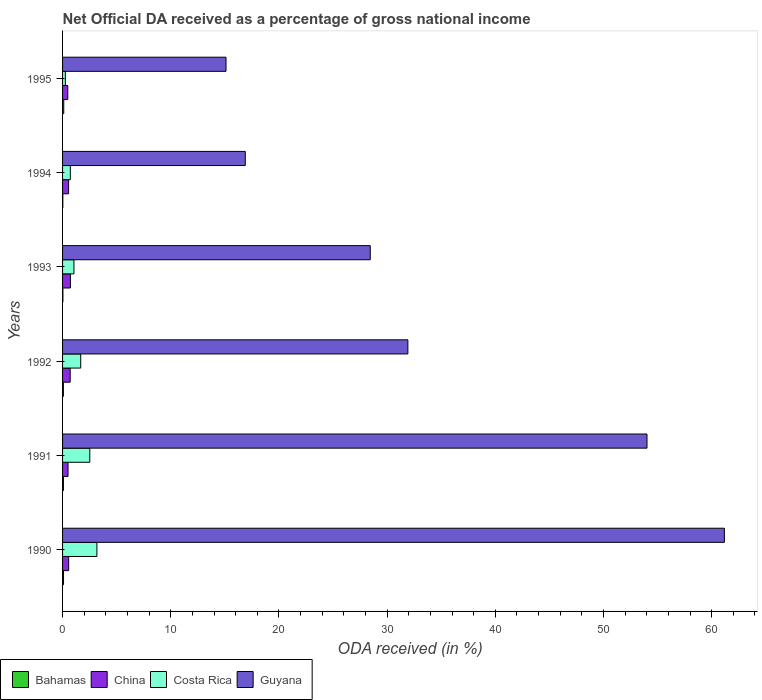How many bars are there on the 6th tick from the top?
Your response must be concise. 4. How many bars are there on the 3rd tick from the bottom?
Your answer should be compact. 4. What is the net official DA received in Costa Rica in 1993?
Offer a very short reply. 1.05. Across all years, what is the maximum net official DA received in China?
Keep it short and to the point. 0.73. Across all years, what is the minimum net official DA received in Guyana?
Provide a succinct answer. 15.11. What is the total net official DA received in Guyana in the graph?
Your answer should be very brief. 207.54. What is the difference between the net official DA received in Costa Rica in 1990 and that in 1995?
Offer a terse response. 2.92. What is the difference between the net official DA received in Bahamas in 1994 and the net official DA received in China in 1993?
Your response must be concise. -0.7. What is the average net official DA received in China per year?
Ensure brevity in your answer.  0.59. In the year 1991, what is the difference between the net official DA received in Guyana and net official DA received in Costa Rica?
Your response must be concise. 51.5. What is the ratio of the net official DA received in Costa Rica in 1993 to that in 1995?
Provide a short and direct response. 4.08. Is the net official DA received in Guyana in 1993 less than that in 1995?
Your response must be concise. No. What is the difference between the highest and the second highest net official DA received in China?
Your answer should be very brief. 0.02. What is the difference between the highest and the lowest net official DA received in China?
Offer a very short reply. 0.24. In how many years, is the net official DA received in China greater than the average net official DA received in China taken over all years?
Provide a short and direct response. 2. Is it the case that in every year, the sum of the net official DA received in Bahamas and net official DA received in Costa Rica is greater than the sum of net official DA received in Guyana and net official DA received in China?
Keep it short and to the point. No. What does the 4th bar from the top in 1993 represents?
Provide a succinct answer. Bahamas. Is it the case that in every year, the sum of the net official DA received in Costa Rica and net official DA received in China is greater than the net official DA received in Guyana?
Ensure brevity in your answer.  No. Are all the bars in the graph horizontal?
Provide a succinct answer. Yes. How many years are there in the graph?
Provide a succinct answer. 6. Are the values on the major ticks of X-axis written in scientific E-notation?
Your response must be concise. No. Does the graph contain any zero values?
Ensure brevity in your answer.  No. How are the legend labels stacked?
Offer a very short reply. Horizontal. What is the title of the graph?
Offer a terse response. Net Official DA received as a percentage of gross national income. What is the label or title of the X-axis?
Provide a succinct answer. ODA received (in %). What is the label or title of the Y-axis?
Your answer should be very brief. Years. What is the ODA received (in %) in Bahamas in 1990?
Provide a succinct answer. 0.09. What is the ODA received (in %) of China in 1990?
Provide a succinct answer. 0.56. What is the ODA received (in %) in Costa Rica in 1990?
Offer a very short reply. 3.17. What is the ODA received (in %) of Guyana in 1990?
Provide a succinct answer. 61.17. What is the ODA received (in %) of Bahamas in 1991?
Keep it short and to the point. 0.08. What is the ODA received (in %) in China in 1991?
Offer a very short reply. 0.51. What is the ODA received (in %) in Costa Rica in 1991?
Ensure brevity in your answer.  2.52. What is the ODA received (in %) in Guyana in 1991?
Give a very brief answer. 54.02. What is the ODA received (in %) in Bahamas in 1992?
Offer a terse response. 0.08. What is the ODA received (in %) of China in 1992?
Give a very brief answer. 0.7. What is the ODA received (in %) in Costa Rica in 1992?
Ensure brevity in your answer.  1.68. What is the ODA received (in %) in Guyana in 1992?
Your answer should be compact. 31.92. What is the ODA received (in %) of Bahamas in 1993?
Your response must be concise. 0.03. What is the ODA received (in %) of China in 1993?
Keep it short and to the point. 0.73. What is the ODA received (in %) in Costa Rica in 1993?
Your response must be concise. 1.05. What is the ODA received (in %) of Guyana in 1993?
Make the answer very short. 28.44. What is the ODA received (in %) of Bahamas in 1994?
Give a very brief answer. 0.02. What is the ODA received (in %) of China in 1994?
Offer a terse response. 0.56. What is the ODA received (in %) in Costa Rica in 1994?
Make the answer very short. 0.72. What is the ODA received (in %) of Guyana in 1994?
Provide a short and direct response. 16.89. What is the ODA received (in %) in Bahamas in 1995?
Offer a very short reply. 0.11. What is the ODA received (in %) in China in 1995?
Give a very brief answer. 0.48. What is the ODA received (in %) of Costa Rica in 1995?
Offer a very short reply. 0.26. What is the ODA received (in %) in Guyana in 1995?
Your answer should be very brief. 15.11. Across all years, what is the maximum ODA received (in %) of Bahamas?
Give a very brief answer. 0.11. Across all years, what is the maximum ODA received (in %) of China?
Ensure brevity in your answer.  0.73. Across all years, what is the maximum ODA received (in %) in Costa Rica?
Your answer should be very brief. 3.17. Across all years, what is the maximum ODA received (in %) in Guyana?
Your response must be concise. 61.17. Across all years, what is the minimum ODA received (in %) of Bahamas?
Keep it short and to the point. 0.02. Across all years, what is the minimum ODA received (in %) of China?
Make the answer very short. 0.48. Across all years, what is the minimum ODA received (in %) in Costa Rica?
Provide a short and direct response. 0.26. Across all years, what is the minimum ODA received (in %) of Guyana?
Make the answer very short. 15.11. What is the total ODA received (in %) in Bahamas in the graph?
Offer a very short reply. 0.41. What is the total ODA received (in %) in China in the graph?
Keep it short and to the point. 3.54. What is the total ODA received (in %) of Costa Rica in the graph?
Make the answer very short. 9.4. What is the total ODA received (in %) of Guyana in the graph?
Your answer should be compact. 207.54. What is the difference between the ODA received (in %) of Bahamas in 1990 and that in 1991?
Keep it short and to the point. 0.01. What is the difference between the ODA received (in %) in China in 1990 and that in 1991?
Offer a terse response. 0.06. What is the difference between the ODA received (in %) of Costa Rica in 1990 and that in 1991?
Ensure brevity in your answer.  0.66. What is the difference between the ODA received (in %) of Guyana in 1990 and that in 1991?
Provide a succinct answer. 7.15. What is the difference between the ODA received (in %) in Bahamas in 1990 and that in 1992?
Offer a very short reply. 0.01. What is the difference between the ODA received (in %) in China in 1990 and that in 1992?
Your answer should be very brief. -0.14. What is the difference between the ODA received (in %) in Costa Rica in 1990 and that in 1992?
Keep it short and to the point. 1.5. What is the difference between the ODA received (in %) of Guyana in 1990 and that in 1992?
Provide a succinct answer. 29.26. What is the difference between the ODA received (in %) of Bahamas in 1990 and that in 1993?
Your response must be concise. 0.06. What is the difference between the ODA received (in %) in China in 1990 and that in 1993?
Your answer should be very brief. -0.16. What is the difference between the ODA received (in %) in Costa Rica in 1990 and that in 1993?
Keep it short and to the point. 2.12. What is the difference between the ODA received (in %) in Guyana in 1990 and that in 1993?
Make the answer very short. 32.73. What is the difference between the ODA received (in %) of Bahamas in 1990 and that in 1994?
Keep it short and to the point. 0.07. What is the difference between the ODA received (in %) in China in 1990 and that in 1994?
Offer a terse response. 0.01. What is the difference between the ODA received (in %) of Costa Rica in 1990 and that in 1994?
Provide a succinct answer. 2.46. What is the difference between the ODA received (in %) of Guyana in 1990 and that in 1994?
Your answer should be very brief. 44.28. What is the difference between the ODA received (in %) of Bahamas in 1990 and that in 1995?
Your answer should be compact. -0.02. What is the difference between the ODA received (in %) of China in 1990 and that in 1995?
Give a very brief answer. 0.08. What is the difference between the ODA received (in %) in Costa Rica in 1990 and that in 1995?
Provide a succinct answer. 2.92. What is the difference between the ODA received (in %) in Guyana in 1990 and that in 1995?
Give a very brief answer. 46.07. What is the difference between the ODA received (in %) in Bahamas in 1991 and that in 1992?
Provide a short and direct response. 0. What is the difference between the ODA received (in %) of China in 1991 and that in 1992?
Give a very brief answer. -0.2. What is the difference between the ODA received (in %) of Costa Rica in 1991 and that in 1992?
Provide a short and direct response. 0.84. What is the difference between the ODA received (in %) in Guyana in 1991 and that in 1992?
Your answer should be compact. 22.1. What is the difference between the ODA received (in %) of Bahamas in 1991 and that in 1993?
Your response must be concise. 0.05. What is the difference between the ODA received (in %) in China in 1991 and that in 1993?
Your response must be concise. -0.22. What is the difference between the ODA received (in %) in Costa Rica in 1991 and that in 1993?
Provide a short and direct response. 1.46. What is the difference between the ODA received (in %) in Guyana in 1991 and that in 1993?
Your answer should be compact. 25.58. What is the difference between the ODA received (in %) of Bahamas in 1991 and that in 1994?
Your answer should be compact. 0.06. What is the difference between the ODA received (in %) in China in 1991 and that in 1994?
Offer a very short reply. -0.05. What is the difference between the ODA received (in %) of Costa Rica in 1991 and that in 1994?
Ensure brevity in your answer.  1.8. What is the difference between the ODA received (in %) in Guyana in 1991 and that in 1994?
Offer a terse response. 37.13. What is the difference between the ODA received (in %) in Bahamas in 1991 and that in 1995?
Give a very brief answer. -0.03. What is the difference between the ODA received (in %) of China in 1991 and that in 1995?
Give a very brief answer. 0.02. What is the difference between the ODA received (in %) in Costa Rica in 1991 and that in 1995?
Keep it short and to the point. 2.26. What is the difference between the ODA received (in %) of Guyana in 1991 and that in 1995?
Give a very brief answer. 38.91. What is the difference between the ODA received (in %) of Bahamas in 1992 and that in 1993?
Make the answer very short. 0.05. What is the difference between the ODA received (in %) in China in 1992 and that in 1993?
Offer a very short reply. -0.02. What is the difference between the ODA received (in %) in Costa Rica in 1992 and that in 1993?
Your answer should be compact. 0.62. What is the difference between the ODA received (in %) of Guyana in 1992 and that in 1993?
Offer a terse response. 3.48. What is the difference between the ODA received (in %) of Bahamas in 1992 and that in 1994?
Make the answer very short. 0.05. What is the difference between the ODA received (in %) of China in 1992 and that in 1994?
Ensure brevity in your answer.  0.14. What is the difference between the ODA received (in %) in Costa Rica in 1992 and that in 1994?
Offer a very short reply. 0.96. What is the difference between the ODA received (in %) in Guyana in 1992 and that in 1994?
Make the answer very short. 15.03. What is the difference between the ODA received (in %) in Bahamas in 1992 and that in 1995?
Your response must be concise. -0.03. What is the difference between the ODA received (in %) in China in 1992 and that in 1995?
Offer a terse response. 0.22. What is the difference between the ODA received (in %) in Costa Rica in 1992 and that in 1995?
Offer a terse response. 1.42. What is the difference between the ODA received (in %) of Guyana in 1992 and that in 1995?
Your response must be concise. 16.81. What is the difference between the ODA received (in %) of Bahamas in 1993 and that in 1994?
Ensure brevity in your answer.  0.01. What is the difference between the ODA received (in %) in China in 1993 and that in 1994?
Make the answer very short. 0.17. What is the difference between the ODA received (in %) in Costa Rica in 1993 and that in 1994?
Offer a very short reply. 0.34. What is the difference between the ODA received (in %) in Guyana in 1993 and that in 1994?
Your answer should be very brief. 11.55. What is the difference between the ODA received (in %) in Bahamas in 1993 and that in 1995?
Offer a terse response. -0.08. What is the difference between the ODA received (in %) of China in 1993 and that in 1995?
Give a very brief answer. 0.24. What is the difference between the ODA received (in %) of Costa Rica in 1993 and that in 1995?
Provide a succinct answer. 0.8. What is the difference between the ODA received (in %) of Guyana in 1993 and that in 1995?
Offer a terse response. 13.33. What is the difference between the ODA received (in %) of Bahamas in 1994 and that in 1995?
Make the answer very short. -0.09. What is the difference between the ODA received (in %) of China in 1994 and that in 1995?
Offer a very short reply. 0.08. What is the difference between the ODA received (in %) of Costa Rica in 1994 and that in 1995?
Make the answer very short. 0.46. What is the difference between the ODA received (in %) of Guyana in 1994 and that in 1995?
Keep it short and to the point. 1.78. What is the difference between the ODA received (in %) in Bahamas in 1990 and the ODA received (in %) in China in 1991?
Offer a very short reply. -0.42. What is the difference between the ODA received (in %) of Bahamas in 1990 and the ODA received (in %) of Costa Rica in 1991?
Keep it short and to the point. -2.43. What is the difference between the ODA received (in %) in Bahamas in 1990 and the ODA received (in %) in Guyana in 1991?
Make the answer very short. -53.93. What is the difference between the ODA received (in %) of China in 1990 and the ODA received (in %) of Costa Rica in 1991?
Ensure brevity in your answer.  -1.95. What is the difference between the ODA received (in %) of China in 1990 and the ODA received (in %) of Guyana in 1991?
Ensure brevity in your answer.  -53.45. What is the difference between the ODA received (in %) of Costa Rica in 1990 and the ODA received (in %) of Guyana in 1991?
Your response must be concise. -50.84. What is the difference between the ODA received (in %) in Bahamas in 1990 and the ODA received (in %) in China in 1992?
Provide a succinct answer. -0.62. What is the difference between the ODA received (in %) of Bahamas in 1990 and the ODA received (in %) of Costa Rica in 1992?
Keep it short and to the point. -1.59. What is the difference between the ODA received (in %) of Bahamas in 1990 and the ODA received (in %) of Guyana in 1992?
Offer a terse response. -31.83. What is the difference between the ODA received (in %) of China in 1990 and the ODA received (in %) of Costa Rica in 1992?
Ensure brevity in your answer.  -1.11. What is the difference between the ODA received (in %) in China in 1990 and the ODA received (in %) in Guyana in 1992?
Make the answer very short. -31.35. What is the difference between the ODA received (in %) of Costa Rica in 1990 and the ODA received (in %) of Guyana in 1992?
Provide a short and direct response. -28.74. What is the difference between the ODA received (in %) in Bahamas in 1990 and the ODA received (in %) in China in 1993?
Provide a short and direct response. -0.64. What is the difference between the ODA received (in %) of Bahamas in 1990 and the ODA received (in %) of Costa Rica in 1993?
Your response must be concise. -0.96. What is the difference between the ODA received (in %) in Bahamas in 1990 and the ODA received (in %) in Guyana in 1993?
Provide a succinct answer. -28.35. What is the difference between the ODA received (in %) of China in 1990 and the ODA received (in %) of Costa Rica in 1993?
Your answer should be compact. -0.49. What is the difference between the ODA received (in %) of China in 1990 and the ODA received (in %) of Guyana in 1993?
Keep it short and to the point. -27.88. What is the difference between the ODA received (in %) of Costa Rica in 1990 and the ODA received (in %) of Guyana in 1993?
Offer a terse response. -25.27. What is the difference between the ODA received (in %) of Bahamas in 1990 and the ODA received (in %) of China in 1994?
Offer a terse response. -0.47. What is the difference between the ODA received (in %) of Bahamas in 1990 and the ODA received (in %) of Costa Rica in 1994?
Make the answer very short. -0.63. What is the difference between the ODA received (in %) of Bahamas in 1990 and the ODA received (in %) of Guyana in 1994?
Keep it short and to the point. -16.8. What is the difference between the ODA received (in %) of China in 1990 and the ODA received (in %) of Costa Rica in 1994?
Offer a terse response. -0.15. What is the difference between the ODA received (in %) of China in 1990 and the ODA received (in %) of Guyana in 1994?
Your response must be concise. -16.32. What is the difference between the ODA received (in %) of Costa Rica in 1990 and the ODA received (in %) of Guyana in 1994?
Make the answer very short. -13.71. What is the difference between the ODA received (in %) of Bahamas in 1990 and the ODA received (in %) of China in 1995?
Keep it short and to the point. -0.39. What is the difference between the ODA received (in %) of Bahamas in 1990 and the ODA received (in %) of Costa Rica in 1995?
Your response must be concise. -0.17. What is the difference between the ODA received (in %) of Bahamas in 1990 and the ODA received (in %) of Guyana in 1995?
Provide a succinct answer. -15.02. What is the difference between the ODA received (in %) in China in 1990 and the ODA received (in %) in Costa Rica in 1995?
Ensure brevity in your answer.  0.31. What is the difference between the ODA received (in %) in China in 1990 and the ODA received (in %) in Guyana in 1995?
Offer a very short reply. -14.54. What is the difference between the ODA received (in %) of Costa Rica in 1990 and the ODA received (in %) of Guyana in 1995?
Offer a very short reply. -11.93. What is the difference between the ODA received (in %) of Bahamas in 1991 and the ODA received (in %) of China in 1992?
Provide a succinct answer. -0.62. What is the difference between the ODA received (in %) in Bahamas in 1991 and the ODA received (in %) in Costa Rica in 1992?
Your answer should be very brief. -1.6. What is the difference between the ODA received (in %) of Bahamas in 1991 and the ODA received (in %) of Guyana in 1992?
Your answer should be compact. -31.84. What is the difference between the ODA received (in %) of China in 1991 and the ODA received (in %) of Costa Rica in 1992?
Offer a very short reply. -1.17. What is the difference between the ODA received (in %) of China in 1991 and the ODA received (in %) of Guyana in 1992?
Provide a short and direct response. -31.41. What is the difference between the ODA received (in %) in Costa Rica in 1991 and the ODA received (in %) in Guyana in 1992?
Offer a very short reply. -29.4. What is the difference between the ODA received (in %) in Bahamas in 1991 and the ODA received (in %) in China in 1993?
Offer a terse response. -0.65. What is the difference between the ODA received (in %) of Bahamas in 1991 and the ODA received (in %) of Costa Rica in 1993?
Provide a succinct answer. -0.97. What is the difference between the ODA received (in %) of Bahamas in 1991 and the ODA received (in %) of Guyana in 1993?
Ensure brevity in your answer.  -28.36. What is the difference between the ODA received (in %) in China in 1991 and the ODA received (in %) in Costa Rica in 1993?
Your answer should be very brief. -0.55. What is the difference between the ODA received (in %) in China in 1991 and the ODA received (in %) in Guyana in 1993?
Ensure brevity in your answer.  -27.93. What is the difference between the ODA received (in %) in Costa Rica in 1991 and the ODA received (in %) in Guyana in 1993?
Make the answer very short. -25.92. What is the difference between the ODA received (in %) of Bahamas in 1991 and the ODA received (in %) of China in 1994?
Give a very brief answer. -0.48. What is the difference between the ODA received (in %) in Bahamas in 1991 and the ODA received (in %) in Costa Rica in 1994?
Keep it short and to the point. -0.64. What is the difference between the ODA received (in %) of Bahamas in 1991 and the ODA received (in %) of Guyana in 1994?
Provide a succinct answer. -16.81. What is the difference between the ODA received (in %) in China in 1991 and the ODA received (in %) in Costa Rica in 1994?
Keep it short and to the point. -0.21. What is the difference between the ODA received (in %) in China in 1991 and the ODA received (in %) in Guyana in 1994?
Provide a short and direct response. -16.38. What is the difference between the ODA received (in %) in Costa Rica in 1991 and the ODA received (in %) in Guyana in 1994?
Ensure brevity in your answer.  -14.37. What is the difference between the ODA received (in %) of Bahamas in 1991 and the ODA received (in %) of China in 1995?
Keep it short and to the point. -0.4. What is the difference between the ODA received (in %) of Bahamas in 1991 and the ODA received (in %) of Costa Rica in 1995?
Your answer should be very brief. -0.18. What is the difference between the ODA received (in %) in Bahamas in 1991 and the ODA received (in %) in Guyana in 1995?
Provide a short and direct response. -15.03. What is the difference between the ODA received (in %) of China in 1991 and the ODA received (in %) of Costa Rica in 1995?
Provide a short and direct response. 0.25. What is the difference between the ODA received (in %) in China in 1991 and the ODA received (in %) in Guyana in 1995?
Ensure brevity in your answer.  -14.6. What is the difference between the ODA received (in %) of Costa Rica in 1991 and the ODA received (in %) of Guyana in 1995?
Ensure brevity in your answer.  -12.59. What is the difference between the ODA received (in %) in Bahamas in 1992 and the ODA received (in %) in China in 1993?
Provide a succinct answer. -0.65. What is the difference between the ODA received (in %) in Bahamas in 1992 and the ODA received (in %) in Costa Rica in 1993?
Give a very brief answer. -0.98. What is the difference between the ODA received (in %) of Bahamas in 1992 and the ODA received (in %) of Guyana in 1993?
Your answer should be very brief. -28.36. What is the difference between the ODA received (in %) in China in 1992 and the ODA received (in %) in Costa Rica in 1993?
Provide a short and direct response. -0.35. What is the difference between the ODA received (in %) in China in 1992 and the ODA received (in %) in Guyana in 1993?
Your response must be concise. -27.74. What is the difference between the ODA received (in %) of Costa Rica in 1992 and the ODA received (in %) of Guyana in 1993?
Your response must be concise. -26.76. What is the difference between the ODA received (in %) in Bahamas in 1992 and the ODA received (in %) in China in 1994?
Make the answer very short. -0.48. What is the difference between the ODA received (in %) of Bahamas in 1992 and the ODA received (in %) of Costa Rica in 1994?
Your answer should be very brief. -0.64. What is the difference between the ODA received (in %) in Bahamas in 1992 and the ODA received (in %) in Guyana in 1994?
Your answer should be very brief. -16.81. What is the difference between the ODA received (in %) in China in 1992 and the ODA received (in %) in Costa Rica in 1994?
Offer a very short reply. -0.01. What is the difference between the ODA received (in %) in China in 1992 and the ODA received (in %) in Guyana in 1994?
Ensure brevity in your answer.  -16.18. What is the difference between the ODA received (in %) in Costa Rica in 1992 and the ODA received (in %) in Guyana in 1994?
Make the answer very short. -15.21. What is the difference between the ODA received (in %) in Bahamas in 1992 and the ODA received (in %) in China in 1995?
Offer a terse response. -0.41. What is the difference between the ODA received (in %) in Bahamas in 1992 and the ODA received (in %) in Costa Rica in 1995?
Give a very brief answer. -0.18. What is the difference between the ODA received (in %) of Bahamas in 1992 and the ODA received (in %) of Guyana in 1995?
Give a very brief answer. -15.03. What is the difference between the ODA received (in %) of China in 1992 and the ODA received (in %) of Costa Rica in 1995?
Offer a terse response. 0.45. What is the difference between the ODA received (in %) in China in 1992 and the ODA received (in %) in Guyana in 1995?
Give a very brief answer. -14.4. What is the difference between the ODA received (in %) of Costa Rica in 1992 and the ODA received (in %) of Guyana in 1995?
Provide a succinct answer. -13.43. What is the difference between the ODA received (in %) in Bahamas in 1993 and the ODA received (in %) in China in 1994?
Ensure brevity in your answer.  -0.53. What is the difference between the ODA received (in %) in Bahamas in 1993 and the ODA received (in %) in Costa Rica in 1994?
Ensure brevity in your answer.  -0.69. What is the difference between the ODA received (in %) in Bahamas in 1993 and the ODA received (in %) in Guyana in 1994?
Make the answer very short. -16.86. What is the difference between the ODA received (in %) of China in 1993 and the ODA received (in %) of Costa Rica in 1994?
Provide a succinct answer. 0.01. What is the difference between the ODA received (in %) in China in 1993 and the ODA received (in %) in Guyana in 1994?
Keep it short and to the point. -16.16. What is the difference between the ODA received (in %) in Costa Rica in 1993 and the ODA received (in %) in Guyana in 1994?
Make the answer very short. -15.83. What is the difference between the ODA received (in %) of Bahamas in 1993 and the ODA received (in %) of China in 1995?
Give a very brief answer. -0.45. What is the difference between the ODA received (in %) in Bahamas in 1993 and the ODA received (in %) in Costa Rica in 1995?
Offer a very short reply. -0.23. What is the difference between the ODA received (in %) of Bahamas in 1993 and the ODA received (in %) of Guyana in 1995?
Your answer should be compact. -15.08. What is the difference between the ODA received (in %) in China in 1993 and the ODA received (in %) in Costa Rica in 1995?
Offer a very short reply. 0.47. What is the difference between the ODA received (in %) of China in 1993 and the ODA received (in %) of Guyana in 1995?
Provide a short and direct response. -14.38. What is the difference between the ODA received (in %) in Costa Rica in 1993 and the ODA received (in %) in Guyana in 1995?
Your answer should be very brief. -14.05. What is the difference between the ODA received (in %) in Bahamas in 1994 and the ODA received (in %) in China in 1995?
Offer a terse response. -0.46. What is the difference between the ODA received (in %) in Bahamas in 1994 and the ODA received (in %) in Costa Rica in 1995?
Ensure brevity in your answer.  -0.23. What is the difference between the ODA received (in %) in Bahamas in 1994 and the ODA received (in %) in Guyana in 1995?
Provide a succinct answer. -15.08. What is the difference between the ODA received (in %) of China in 1994 and the ODA received (in %) of Costa Rica in 1995?
Your answer should be compact. 0.3. What is the difference between the ODA received (in %) of China in 1994 and the ODA received (in %) of Guyana in 1995?
Keep it short and to the point. -14.55. What is the difference between the ODA received (in %) of Costa Rica in 1994 and the ODA received (in %) of Guyana in 1995?
Keep it short and to the point. -14.39. What is the average ODA received (in %) of Bahamas per year?
Offer a terse response. 0.07. What is the average ODA received (in %) of China per year?
Provide a short and direct response. 0.59. What is the average ODA received (in %) in Costa Rica per year?
Ensure brevity in your answer.  1.57. What is the average ODA received (in %) in Guyana per year?
Offer a very short reply. 34.59. In the year 1990, what is the difference between the ODA received (in %) in Bahamas and ODA received (in %) in China?
Provide a short and direct response. -0.48. In the year 1990, what is the difference between the ODA received (in %) in Bahamas and ODA received (in %) in Costa Rica?
Keep it short and to the point. -3.09. In the year 1990, what is the difference between the ODA received (in %) of Bahamas and ODA received (in %) of Guyana?
Give a very brief answer. -61.08. In the year 1990, what is the difference between the ODA received (in %) in China and ODA received (in %) in Costa Rica?
Your answer should be very brief. -2.61. In the year 1990, what is the difference between the ODA received (in %) of China and ODA received (in %) of Guyana?
Offer a very short reply. -60.61. In the year 1990, what is the difference between the ODA received (in %) in Costa Rica and ODA received (in %) in Guyana?
Your answer should be very brief. -58. In the year 1991, what is the difference between the ODA received (in %) of Bahamas and ODA received (in %) of China?
Provide a short and direct response. -0.43. In the year 1991, what is the difference between the ODA received (in %) in Bahamas and ODA received (in %) in Costa Rica?
Your answer should be compact. -2.44. In the year 1991, what is the difference between the ODA received (in %) in Bahamas and ODA received (in %) in Guyana?
Make the answer very short. -53.94. In the year 1991, what is the difference between the ODA received (in %) of China and ODA received (in %) of Costa Rica?
Make the answer very short. -2.01. In the year 1991, what is the difference between the ODA received (in %) of China and ODA received (in %) of Guyana?
Offer a terse response. -53.51. In the year 1991, what is the difference between the ODA received (in %) in Costa Rica and ODA received (in %) in Guyana?
Give a very brief answer. -51.5. In the year 1992, what is the difference between the ODA received (in %) of Bahamas and ODA received (in %) of China?
Give a very brief answer. -0.63. In the year 1992, what is the difference between the ODA received (in %) of Bahamas and ODA received (in %) of Costa Rica?
Provide a short and direct response. -1.6. In the year 1992, what is the difference between the ODA received (in %) in Bahamas and ODA received (in %) in Guyana?
Provide a succinct answer. -31.84. In the year 1992, what is the difference between the ODA received (in %) of China and ODA received (in %) of Costa Rica?
Offer a terse response. -0.97. In the year 1992, what is the difference between the ODA received (in %) of China and ODA received (in %) of Guyana?
Give a very brief answer. -31.21. In the year 1992, what is the difference between the ODA received (in %) of Costa Rica and ODA received (in %) of Guyana?
Your answer should be very brief. -30.24. In the year 1993, what is the difference between the ODA received (in %) in Bahamas and ODA received (in %) in China?
Keep it short and to the point. -0.7. In the year 1993, what is the difference between the ODA received (in %) of Bahamas and ODA received (in %) of Costa Rica?
Provide a short and direct response. -1.02. In the year 1993, what is the difference between the ODA received (in %) in Bahamas and ODA received (in %) in Guyana?
Offer a very short reply. -28.41. In the year 1993, what is the difference between the ODA received (in %) in China and ODA received (in %) in Costa Rica?
Provide a short and direct response. -0.33. In the year 1993, what is the difference between the ODA received (in %) in China and ODA received (in %) in Guyana?
Provide a short and direct response. -27.71. In the year 1993, what is the difference between the ODA received (in %) in Costa Rica and ODA received (in %) in Guyana?
Provide a short and direct response. -27.39. In the year 1994, what is the difference between the ODA received (in %) in Bahamas and ODA received (in %) in China?
Your answer should be compact. -0.54. In the year 1994, what is the difference between the ODA received (in %) in Bahamas and ODA received (in %) in Costa Rica?
Offer a terse response. -0.69. In the year 1994, what is the difference between the ODA received (in %) of Bahamas and ODA received (in %) of Guyana?
Your answer should be compact. -16.86. In the year 1994, what is the difference between the ODA received (in %) in China and ODA received (in %) in Costa Rica?
Your answer should be very brief. -0.16. In the year 1994, what is the difference between the ODA received (in %) of China and ODA received (in %) of Guyana?
Your response must be concise. -16.33. In the year 1994, what is the difference between the ODA received (in %) in Costa Rica and ODA received (in %) in Guyana?
Provide a short and direct response. -16.17. In the year 1995, what is the difference between the ODA received (in %) in Bahamas and ODA received (in %) in China?
Provide a succinct answer. -0.37. In the year 1995, what is the difference between the ODA received (in %) of Bahamas and ODA received (in %) of Costa Rica?
Keep it short and to the point. -0.15. In the year 1995, what is the difference between the ODA received (in %) in Bahamas and ODA received (in %) in Guyana?
Make the answer very short. -15. In the year 1995, what is the difference between the ODA received (in %) in China and ODA received (in %) in Costa Rica?
Your response must be concise. 0.22. In the year 1995, what is the difference between the ODA received (in %) in China and ODA received (in %) in Guyana?
Ensure brevity in your answer.  -14.62. In the year 1995, what is the difference between the ODA received (in %) in Costa Rica and ODA received (in %) in Guyana?
Keep it short and to the point. -14.85. What is the ratio of the ODA received (in %) in Bahamas in 1990 to that in 1991?
Make the answer very short. 1.12. What is the ratio of the ODA received (in %) of China in 1990 to that in 1991?
Offer a terse response. 1.12. What is the ratio of the ODA received (in %) in Costa Rica in 1990 to that in 1991?
Ensure brevity in your answer.  1.26. What is the ratio of the ODA received (in %) of Guyana in 1990 to that in 1991?
Make the answer very short. 1.13. What is the ratio of the ODA received (in %) of Bahamas in 1990 to that in 1992?
Ensure brevity in your answer.  1.18. What is the ratio of the ODA received (in %) of China in 1990 to that in 1992?
Make the answer very short. 0.8. What is the ratio of the ODA received (in %) of Costa Rica in 1990 to that in 1992?
Provide a short and direct response. 1.89. What is the ratio of the ODA received (in %) in Guyana in 1990 to that in 1992?
Ensure brevity in your answer.  1.92. What is the ratio of the ODA received (in %) in Bahamas in 1990 to that in 1993?
Your answer should be very brief. 3.02. What is the ratio of the ODA received (in %) of China in 1990 to that in 1993?
Your answer should be compact. 0.78. What is the ratio of the ODA received (in %) in Costa Rica in 1990 to that in 1993?
Give a very brief answer. 3.01. What is the ratio of the ODA received (in %) of Guyana in 1990 to that in 1993?
Your response must be concise. 2.15. What is the ratio of the ODA received (in %) of Bahamas in 1990 to that in 1994?
Provide a short and direct response. 3.76. What is the ratio of the ODA received (in %) of China in 1990 to that in 1994?
Make the answer very short. 1.01. What is the ratio of the ODA received (in %) in Costa Rica in 1990 to that in 1994?
Provide a short and direct response. 4.42. What is the ratio of the ODA received (in %) in Guyana in 1990 to that in 1994?
Provide a short and direct response. 3.62. What is the ratio of the ODA received (in %) of Bahamas in 1990 to that in 1995?
Provide a short and direct response. 0.81. What is the ratio of the ODA received (in %) in China in 1990 to that in 1995?
Offer a terse response. 1.17. What is the ratio of the ODA received (in %) in Costa Rica in 1990 to that in 1995?
Your response must be concise. 12.3. What is the ratio of the ODA received (in %) in Guyana in 1990 to that in 1995?
Offer a terse response. 4.05. What is the ratio of the ODA received (in %) of Bahamas in 1991 to that in 1992?
Your answer should be very brief. 1.05. What is the ratio of the ODA received (in %) of China in 1991 to that in 1992?
Your response must be concise. 0.72. What is the ratio of the ODA received (in %) of Guyana in 1991 to that in 1992?
Your response must be concise. 1.69. What is the ratio of the ODA received (in %) in Bahamas in 1991 to that in 1993?
Give a very brief answer. 2.69. What is the ratio of the ODA received (in %) of China in 1991 to that in 1993?
Offer a very short reply. 0.7. What is the ratio of the ODA received (in %) of Costa Rica in 1991 to that in 1993?
Give a very brief answer. 2.39. What is the ratio of the ODA received (in %) in Guyana in 1991 to that in 1993?
Your answer should be compact. 1.9. What is the ratio of the ODA received (in %) in Bahamas in 1991 to that in 1994?
Give a very brief answer. 3.35. What is the ratio of the ODA received (in %) of China in 1991 to that in 1994?
Provide a short and direct response. 0.9. What is the ratio of the ODA received (in %) of Costa Rica in 1991 to that in 1994?
Provide a succinct answer. 3.51. What is the ratio of the ODA received (in %) of Guyana in 1991 to that in 1994?
Make the answer very short. 3.2. What is the ratio of the ODA received (in %) in Bahamas in 1991 to that in 1995?
Keep it short and to the point. 0.72. What is the ratio of the ODA received (in %) in China in 1991 to that in 1995?
Your answer should be compact. 1.05. What is the ratio of the ODA received (in %) of Costa Rica in 1991 to that in 1995?
Offer a terse response. 9.75. What is the ratio of the ODA received (in %) in Guyana in 1991 to that in 1995?
Give a very brief answer. 3.58. What is the ratio of the ODA received (in %) in Bahamas in 1992 to that in 1993?
Provide a succinct answer. 2.57. What is the ratio of the ODA received (in %) of China in 1992 to that in 1993?
Keep it short and to the point. 0.97. What is the ratio of the ODA received (in %) in Costa Rica in 1992 to that in 1993?
Your response must be concise. 1.59. What is the ratio of the ODA received (in %) of Guyana in 1992 to that in 1993?
Your answer should be very brief. 1.12. What is the ratio of the ODA received (in %) of Bahamas in 1992 to that in 1994?
Your answer should be very brief. 3.2. What is the ratio of the ODA received (in %) of China in 1992 to that in 1994?
Make the answer very short. 1.26. What is the ratio of the ODA received (in %) of Costa Rica in 1992 to that in 1994?
Make the answer very short. 2.34. What is the ratio of the ODA received (in %) in Guyana in 1992 to that in 1994?
Your answer should be very brief. 1.89. What is the ratio of the ODA received (in %) of Bahamas in 1992 to that in 1995?
Offer a very short reply. 0.69. What is the ratio of the ODA received (in %) of China in 1992 to that in 1995?
Your response must be concise. 1.46. What is the ratio of the ODA received (in %) of Costa Rica in 1992 to that in 1995?
Make the answer very short. 6.5. What is the ratio of the ODA received (in %) of Guyana in 1992 to that in 1995?
Provide a succinct answer. 2.11. What is the ratio of the ODA received (in %) in Bahamas in 1993 to that in 1994?
Ensure brevity in your answer.  1.25. What is the ratio of the ODA received (in %) of China in 1993 to that in 1994?
Ensure brevity in your answer.  1.3. What is the ratio of the ODA received (in %) of Costa Rica in 1993 to that in 1994?
Offer a terse response. 1.47. What is the ratio of the ODA received (in %) of Guyana in 1993 to that in 1994?
Your answer should be very brief. 1.68. What is the ratio of the ODA received (in %) of Bahamas in 1993 to that in 1995?
Provide a succinct answer. 0.27. What is the ratio of the ODA received (in %) of China in 1993 to that in 1995?
Your answer should be very brief. 1.51. What is the ratio of the ODA received (in %) in Costa Rica in 1993 to that in 1995?
Provide a short and direct response. 4.08. What is the ratio of the ODA received (in %) of Guyana in 1993 to that in 1995?
Offer a terse response. 1.88. What is the ratio of the ODA received (in %) of Bahamas in 1994 to that in 1995?
Make the answer very short. 0.22. What is the ratio of the ODA received (in %) in China in 1994 to that in 1995?
Offer a very short reply. 1.16. What is the ratio of the ODA received (in %) in Costa Rica in 1994 to that in 1995?
Offer a very short reply. 2.78. What is the ratio of the ODA received (in %) in Guyana in 1994 to that in 1995?
Your answer should be very brief. 1.12. What is the difference between the highest and the second highest ODA received (in %) in Bahamas?
Provide a short and direct response. 0.02. What is the difference between the highest and the second highest ODA received (in %) of China?
Your answer should be compact. 0.02. What is the difference between the highest and the second highest ODA received (in %) in Costa Rica?
Provide a succinct answer. 0.66. What is the difference between the highest and the second highest ODA received (in %) in Guyana?
Provide a short and direct response. 7.15. What is the difference between the highest and the lowest ODA received (in %) of Bahamas?
Keep it short and to the point. 0.09. What is the difference between the highest and the lowest ODA received (in %) of China?
Provide a succinct answer. 0.24. What is the difference between the highest and the lowest ODA received (in %) in Costa Rica?
Keep it short and to the point. 2.92. What is the difference between the highest and the lowest ODA received (in %) in Guyana?
Ensure brevity in your answer.  46.07. 